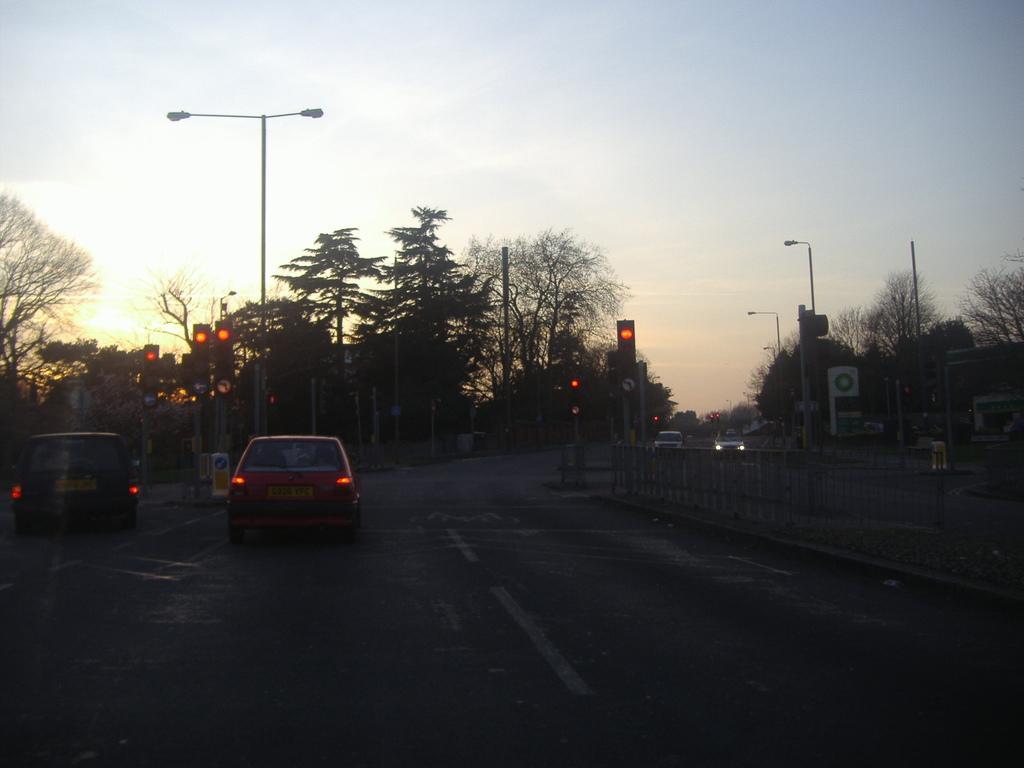Could you give a brief overview of what you see in this image? This picture is clicked outside the city. At the bottom, we see the road. On the right side, we see the steel barriers. On the right side, we see the traffic signals, street lights, poles, buildings and trees. In the middle, we see the cars are moving on the road. On the left side, we see the traffic signals, poles, street lights and trees. At the top, we see the sky and the sun. 